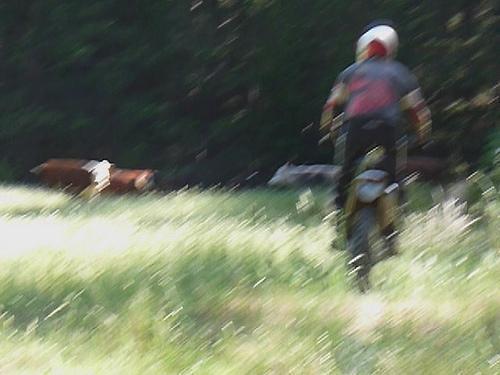How many people are in this photo?
Give a very brief answer. 1. 